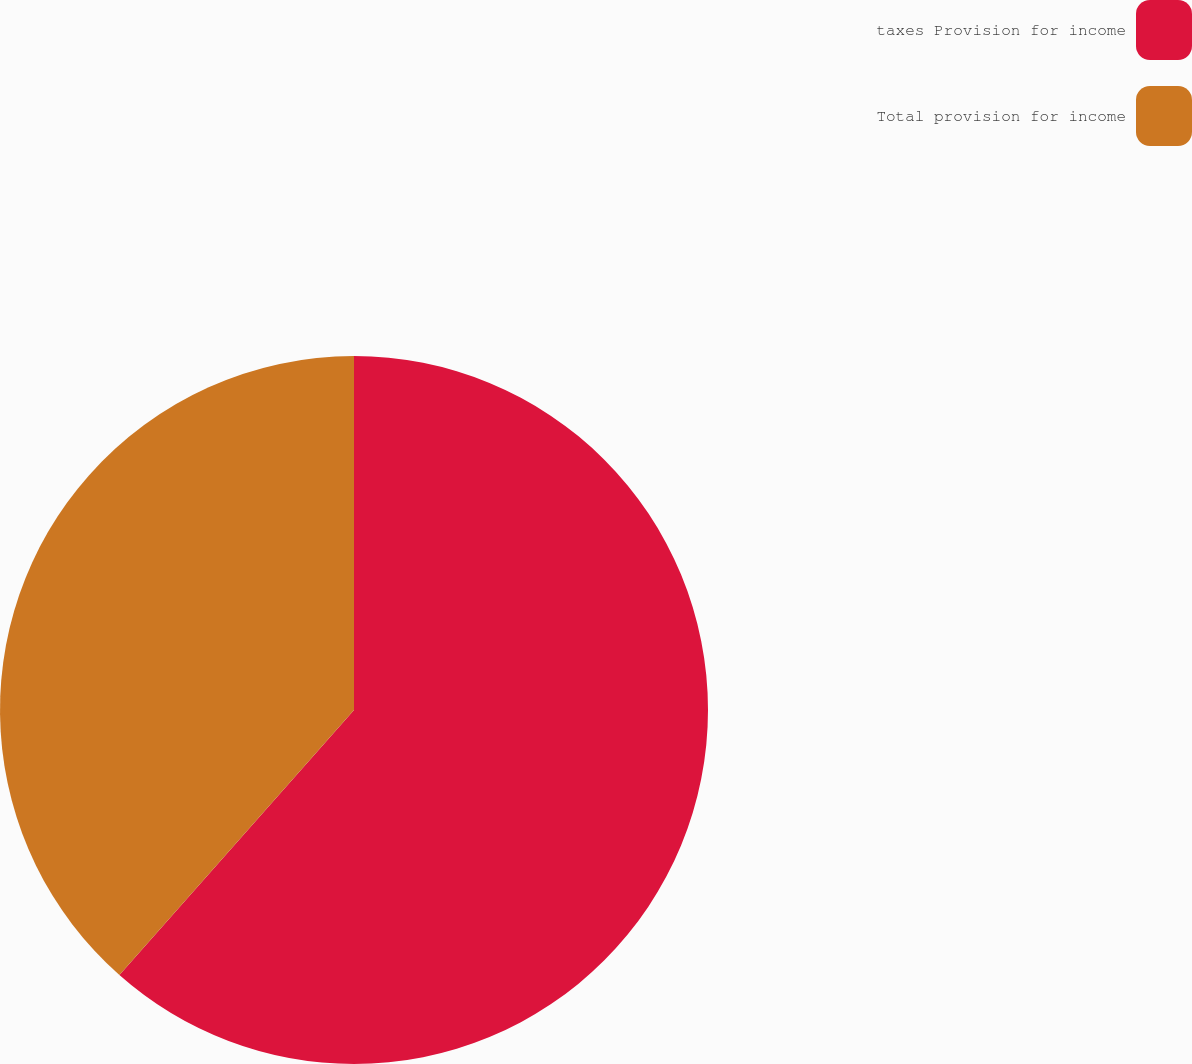Convert chart. <chart><loc_0><loc_0><loc_500><loc_500><pie_chart><fcel>taxes Provision for income<fcel>Total provision for income<nl><fcel>61.53%<fcel>38.47%<nl></chart> 